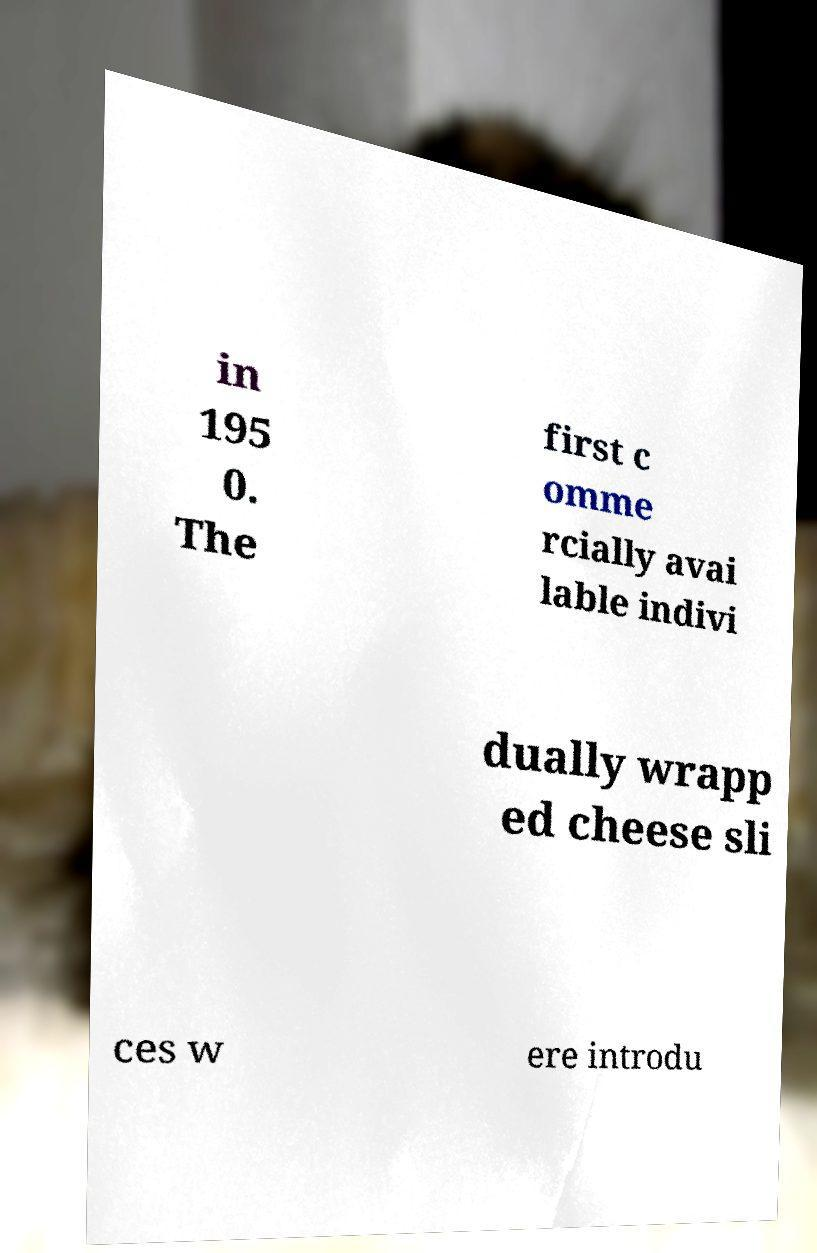For documentation purposes, I need the text within this image transcribed. Could you provide that? in 195 0. The first c omme rcially avai lable indivi dually wrapp ed cheese sli ces w ere introdu 